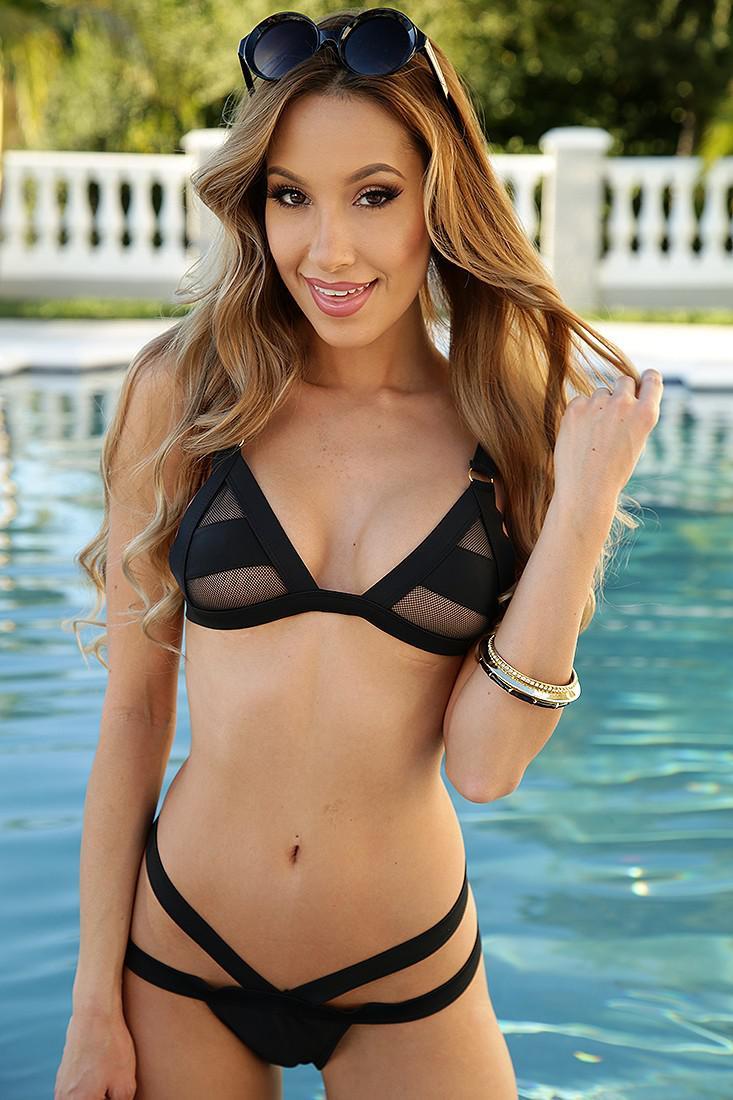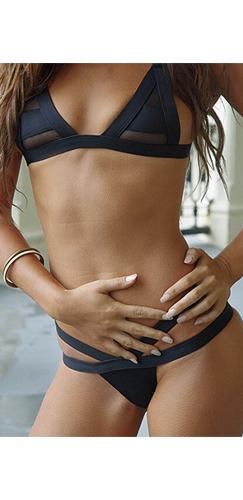The first image is the image on the left, the second image is the image on the right. For the images shown, is this caption "Models wear the same color bikinis in left and right images." true? Answer yes or no. Yes. The first image is the image on the left, the second image is the image on the right. For the images displayed, is the sentence "In one of the images, a woman is wearing a white bikini" factually correct? Answer yes or no. No. 